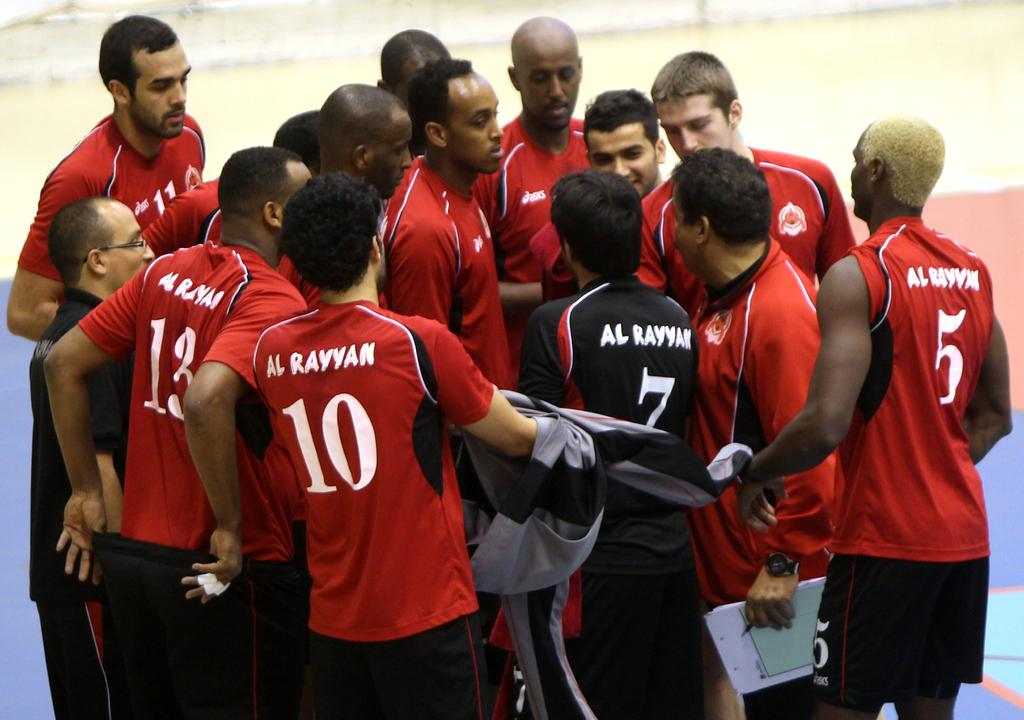<image>
Share a concise interpretation of the image provided. Some sports people huddled together, one of whom wears a number 10 shirt. 